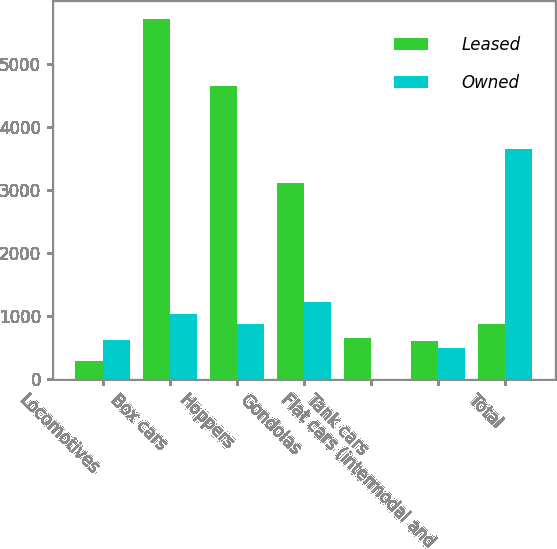Convert chart to OTSL. <chart><loc_0><loc_0><loc_500><loc_500><stacked_bar_chart><ecel><fcel>Locomotives<fcel>Box cars<fcel>Hoppers<fcel>Gondolas<fcel>Tank cars<fcel>Flat cars (intermodal and<fcel>Total<nl><fcel>Leased<fcel>295<fcel>5714<fcel>4644<fcel>3114<fcel>661<fcel>605<fcel>872<nl><fcel>Owned<fcel>628<fcel>1031<fcel>872<fcel>1229<fcel>15<fcel>501<fcel>3648<nl></chart> 